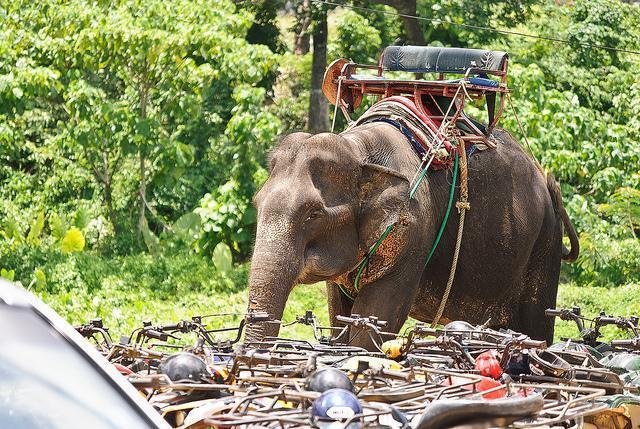How many bicycles are visible?
Give a very brief answer. 3. How many benches are in the photo?
Give a very brief answer. 1. How many people surfing are there?
Give a very brief answer. 0. 